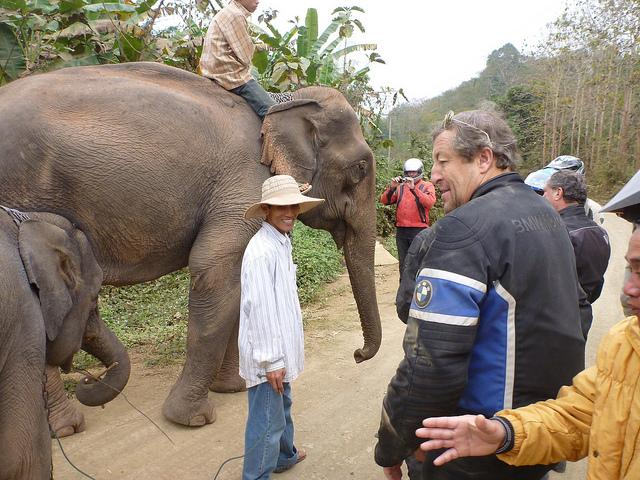Which of these men is most likely from a different country? bmw jacket 